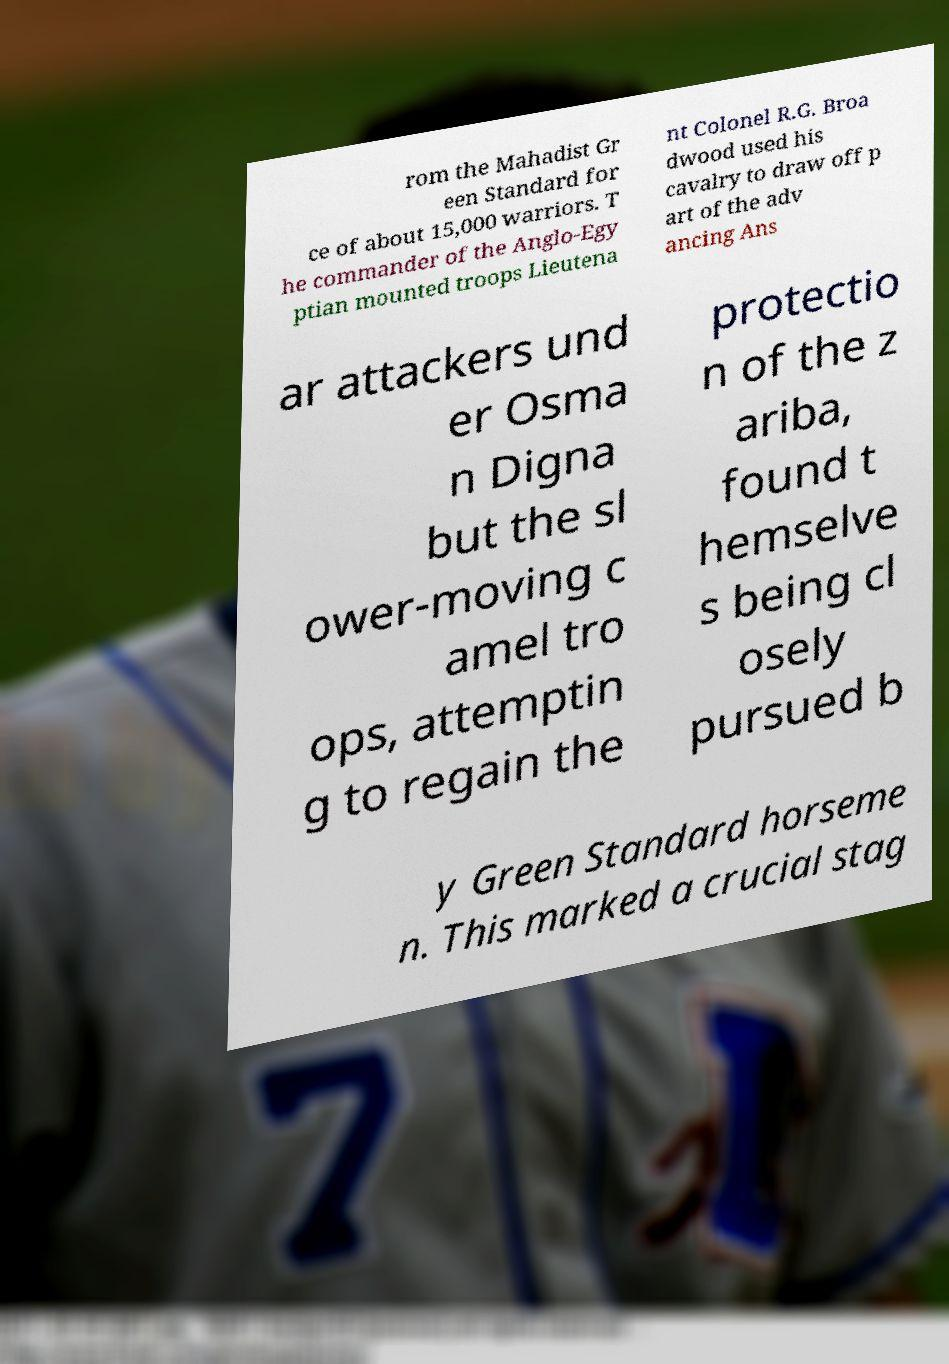I need the written content from this picture converted into text. Can you do that? rom the Mahadist Gr een Standard for ce of about 15,000 warriors. T he commander of the Anglo-Egy ptian mounted troops Lieutena nt Colonel R.G. Broa dwood used his cavalry to draw off p art of the adv ancing Ans ar attackers und er Osma n Digna but the sl ower-moving c amel tro ops, attemptin g to regain the protectio n of the z ariba, found t hemselve s being cl osely pursued b y Green Standard horseme n. This marked a crucial stag 